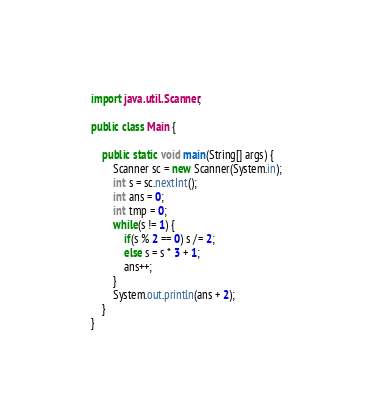<code> <loc_0><loc_0><loc_500><loc_500><_Java_>import java.util.Scanner;

public class Main {

    public static void main(String[] args) {
        Scanner sc = new Scanner(System.in);
        int s = sc.nextInt();
        int ans = 0;
        int tmp = 0;
        while(s != 1) {
            if(s % 2 == 0) s /= 2;
            else s = s * 3 + 1;
            ans++;
        }
        System.out.println(ans + 2);
    }
}</code> 